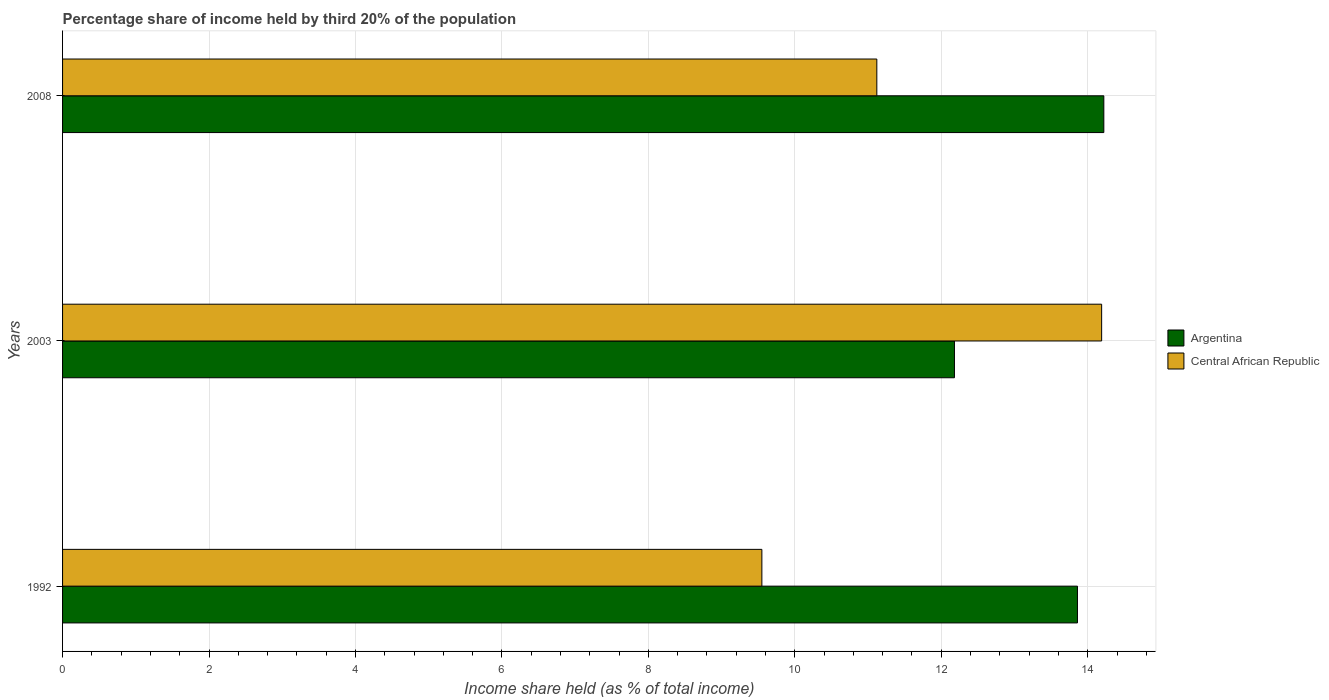How many different coloured bars are there?
Your answer should be compact. 2. How many bars are there on the 3rd tick from the top?
Offer a terse response. 2. In how many cases, is the number of bars for a given year not equal to the number of legend labels?
Your response must be concise. 0. What is the share of income held by third 20% of the population in Argentina in 2003?
Make the answer very short. 12.18. Across all years, what is the maximum share of income held by third 20% of the population in Central African Republic?
Your response must be concise. 14.19. Across all years, what is the minimum share of income held by third 20% of the population in Argentina?
Your answer should be compact. 12.18. What is the total share of income held by third 20% of the population in Central African Republic in the graph?
Your answer should be compact. 34.86. What is the difference between the share of income held by third 20% of the population in Argentina in 2003 and that in 2008?
Make the answer very short. -2.04. What is the difference between the share of income held by third 20% of the population in Central African Republic in 2008 and the share of income held by third 20% of the population in Argentina in 2003?
Your answer should be compact. -1.06. What is the average share of income held by third 20% of the population in Central African Republic per year?
Your answer should be very brief. 11.62. In the year 2008, what is the difference between the share of income held by third 20% of the population in Central African Republic and share of income held by third 20% of the population in Argentina?
Provide a succinct answer. -3.1. What is the ratio of the share of income held by third 20% of the population in Argentina in 2003 to that in 2008?
Keep it short and to the point. 0.86. Is the share of income held by third 20% of the population in Central African Republic in 2003 less than that in 2008?
Keep it short and to the point. No. What is the difference between the highest and the second highest share of income held by third 20% of the population in Argentina?
Your answer should be very brief. 0.36. What is the difference between the highest and the lowest share of income held by third 20% of the population in Central African Republic?
Provide a succinct answer. 4.64. In how many years, is the share of income held by third 20% of the population in Central African Republic greater than the average share of income held by third 20% of the population in Central African Republic taken over all years?
Your response must be concise. 1. Is the sum of the share of income held by third 20% of the population in Argentina in 1992 and 2003 greater than the maximum share of income held by third 20% of the population in Central African Republic across all years?
Provide a short and direct response. Yes. What does the 2nd bar from the bottom in 1992 represents?
Offer a very short reply. Central African Republic. How many bars are there?
Your answer should be very brief. 6. Does the graph contain any zero values?
Your answer should be very brief. No. Does the graph contain grids?
Keep it short and to the point. Yes. Where does the legend appear in the graph?
Offer a terse response. Center right. What is the title of the graph?
Ensure brevity in your answer.  Percentage share of income held by third 20% of the population. What is the label or title of the X-axis?
Provide a succinct answer. Income share held (as % of total income). What is the label or title of the Y-axis?
Keep it short and to the point. Years. What is the Income share held (as % of total income) of Argentina in 1992?
Ensure brevity in your answer.  13.86. What is the Income share held (as % of total income) in Central African Republic in 1992?
Keep it short and to the point. 9.55. What is the Income share held (as % of total income) in Argentina in 2003?
Give a very brief answer. 12.18. What is the Income share held (as % of total income) in Central African Republic in 2003?
Keep it short and to the point. 14.19. What is the Income share held (as % of total income) of Argentina in 2008?
Keep it short and to the point. 14.22. What is the Income share held (as % of total income) in Central African Republic in 2008?
Keep it short and to the point. 11.12. Across all years, what is the maximum Income share held (as % of total income) in Argentina?
Ensure brevity in your answer.  14.22. Across all years, what is the maximum Income share held (as % of total income) of Central African Republic?
Keep it short and to the point. 14.19. Across all years, what is the minimum Income share held (as % of total income) in Argentina?
Your answer should be compact. 12.18. Across all years, what is the minimum Income share held (as % of total income) in Central African Republic?
Give a very brief answer. 9.55. What is the total Income share held (as % of total income) of Argentina in the graph?
Make the answer very short. 40.26. What is the total Income share held (as % of total income) of Central African Republic in the graph?
Provide a succinct answer. 34.86. What is the difference between the Income share held (as % of total income) in Argentina in 1992 and that in 2003?
Provide a short and direct response. 1.68. What is the difference between the Income share held (as % of total income) in Central African Republic in 1992 and that in 2003?
Provide a succinct answer. -4.64. What is the difference between the Income share held (as % of total income) of Argentina in 1992 and that in 2008?
Offer a terse response. -0.36. What is the difference between the Income share held (as % of total income) of Central African Republic in 1992 and that in 2008?
Make the answer very short. -1.57. What is the difference between the Income share held (as % of total income) in Argentina in 2003 and that in 2008?
Offer a terse response. -2.04. What is the difference between the Income share held (as % of total income) in Central African Republic in 2003 and that in 2008?
Your answer should be very brief. 3.07. What is the difference between the Income share held (as % of total income) in Argentina in 1992 and the Income share held (as % of total income) in Central African Republic in 2003?
Your answer should be compact. -0.33. What is the difference between the Income share held (as % of total income) of Argentina in 1992 and the Income share held (as % of total income) of Central African Republic in 2008?
Ensure brevity in your answer.  2.74. What is the difference between the Income share held (as % of total income) in Argentina in 2003 and the Income share held (as % of total income) in Central African Republic in 2008?
Provide a short and direct response. 1.06. What is the average Income share held (as % of total income) of Argentina per year?
Provide a succinct answer. 13.42. What is the average Income share held (as % of total income) in Central African Republic per year?
Offer a terse response. 11.62. In the year 1992, what is the difference between the Income share held (as % of total income) of Argentina and Income share held (as % of total income) of Central African Republic?
Offer a terse response. 4.31. In the year 2003, what is the difference between the Income share held (as % of total income) in Argentina and Income share held (as % of total income) in Central African Republic?
Your answer should be compact. -2.01. What is the ratio of the Income share held (as % of total income) of Argentina in 1992 to that in 2003?
Offer a terse response. 1.14. What is the ratio of the Income share held (as % of total income) of Central African Republic in 1992 to that in 2003?
Provide a short and direct response. 0.67. What is the ratio of the Income share held (as % of total income) of Argentina in 1992 to that in 2008?
Keep it short and to the point. 0.97. What is the ratio of the Income share held (as % of total income) in Central African Republic in 1992 to that in 2008?
Your response must be concise. 0.86. What is the ratio of the Income share held (as % of total income) in Argentina in 2003 to that in 2008?
Offer a terse response. 0.86. What is the ratio of the Income share held (as % of total income) of Central African Republic in 2003 to that in 2008?
Ensure brevity in your answer.  1.28. What is the difference between the highest and the second highest Income share held (as % of total income) of Argentina?
Your answer should be compact. 0.36. What is the difference between the highest and the second highest Income share held (as % of total income) of Central African Republic?
Make the answer very short. 3.07. What is the difference between the highest and the lowest Income share held (as % of total income) of Argentina?
Give a very brief answer. 2.04. What is the difference between the highest and the lowest Income share held (as % of total income) in Central African Republic?
Ensure brevity in your answer.  4.64. 